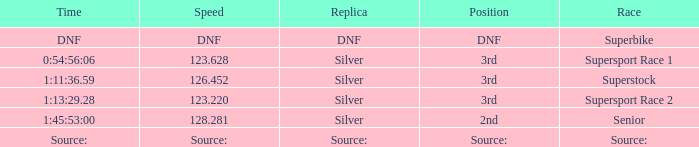Which position has a time of 1:45:53:00? 2nd. Would you mind parsing the complete table? {'header': ['Time', 'Speed', 'Replica', 'Position', 'Race'], 'rows': [['DNF', 'DNF', 'DNF', 'DNF', 'Superbike'], ['0:54:56:06', '123.628', 'Silver', '3rd', 'Supersport Race 1'], ['1:11:36.59', '126.452', 'Silver', '3rd', 'Superstock'], ['1:13:29.28', '123.220', 'Silver', '3rd', 'Supersport Race 2'], ['1:45:53:00', '128.281', 'Silver', '2nd', 'Senior'], ['Source:', 'Source:', 'Source:', 'Source:', 'Source:']]} 